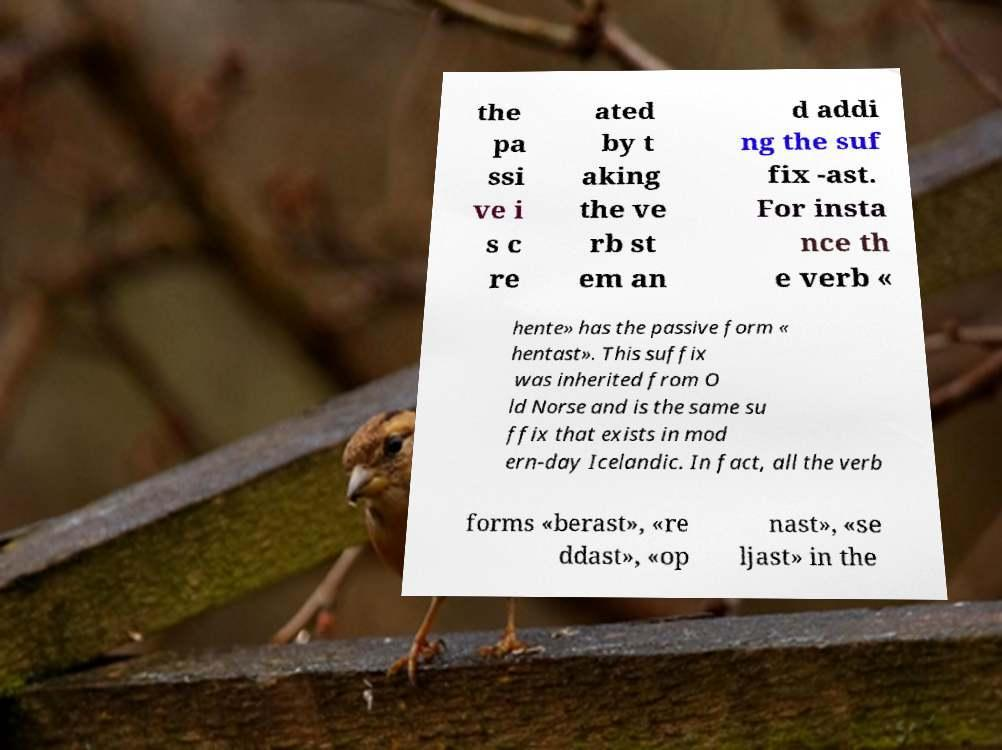What messages or text are displayed in this image? I need them in a readable, typed format. the pa ssi ve i s c re ated by t aking the ve rb st em an d addi ng the suf fix -ast. For insta nce th e verb « hente» has the passive form « hentast». This suffix was inherited from O ld Norse and is the same su ffix that exists in mod ern-day Icelandic. In fact, all the verb forms «berast», «re ddast», «op nast», «se ljast» in the 